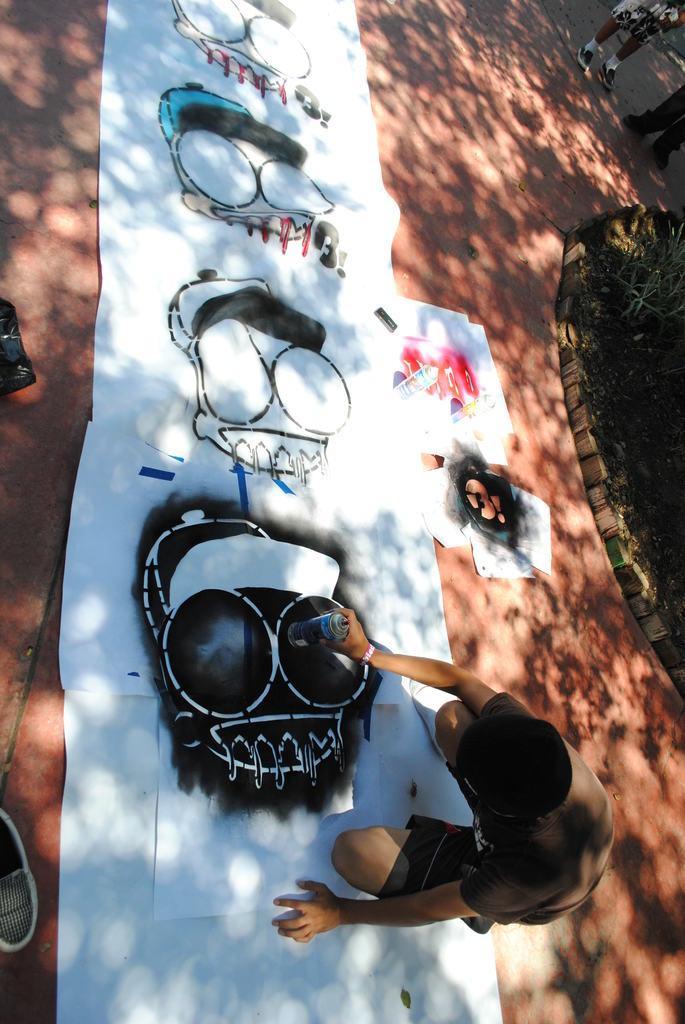Can you describe this image briefly? In this image we can see a person wearing brown color T-shirt crouching and doing some painting on the sheets which are on floor and on right side of the image there are some persons standing and there are some plants. 